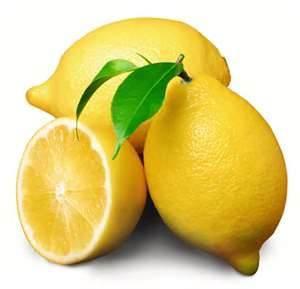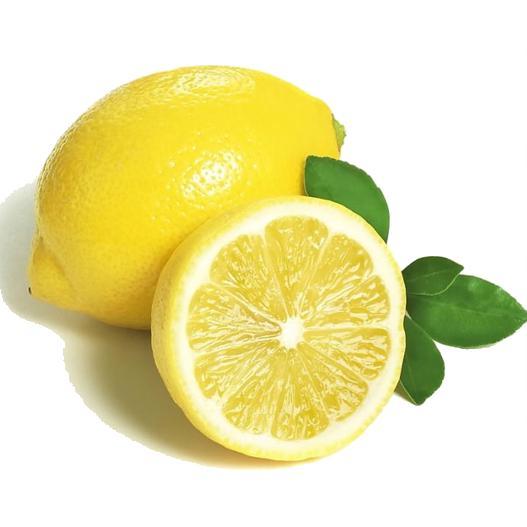The first image is the image on the left, the second image is the image on the right. Analyze the images presented: Is the assertion "the image on the right contains only one full lemon and a half lemon" valid? Answer yes or no. Yes. 